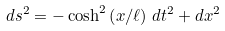Convert formula to latex. <formula><loc_0><loc_0><loc_500><loc_500>d s ^ { 2 } = - \cosh ^ { 2 } \left ( x / \ell \right ) \, d t ^ { 2 } + d x ^ { 2 }</formula> 